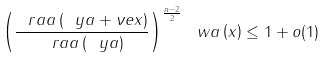Convert formula to latex. <formula><loc_0><loc_0><loc_500><loc_500>\left ( \frac { \ r a a \left ( \ y a + \nu e x \right ) } { \ r a a \left ( \ y a \right ) } \right ) ^ { \frac { n - 2 } { 2 } } \ w a \left ( x \right ) \leq 1 + o ( 1 )</formula> 